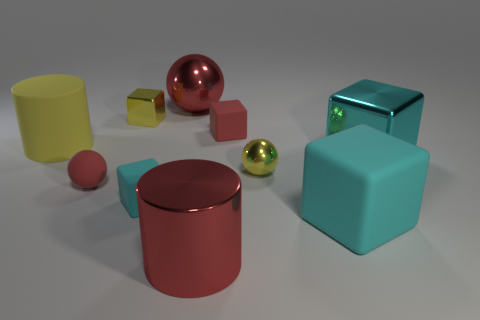What is the shape of the thing that is right of the yellow ball and behind the tiny cyan rubber thing?
Make the answer very short. Cube. What number of small balls are there?
Your answer should be very brief. 2. There is a red thing that is to the left of the tiny yellow thing that is behind the small rubber cube that is behind the small cyan object; what is it made of?
Your response must be concise. Rubber. There is a small yellow thing that is on the right side of the red metallic ball; what number of large yellow matte cylinders are in front of it?
Your answer should be compact. 0. There is another metallic thing that is the same shape as the big cyan metal thing; what is its color?
Ensure brevity in your answer.  Yellow. Does the small cyan block have the same material as the large yellow thing?
Ensure brevity in your answer.  Yes. How many balls are either tiny red things or yellow metallic things?
Your answer should be compact. 2. How big is the red rubber thing in front of the small cube that is on the right side of the cyan thing on the left side of the red metallic sphere?
Make the answer very short. Small. There is a cyan metallic thing that is the same shape as the small cyan matte object; what size is it?
Your answer should be compact. Large. What number of big red spheres are left of the red matte sphere?
Keep it short and to the point. 0. 